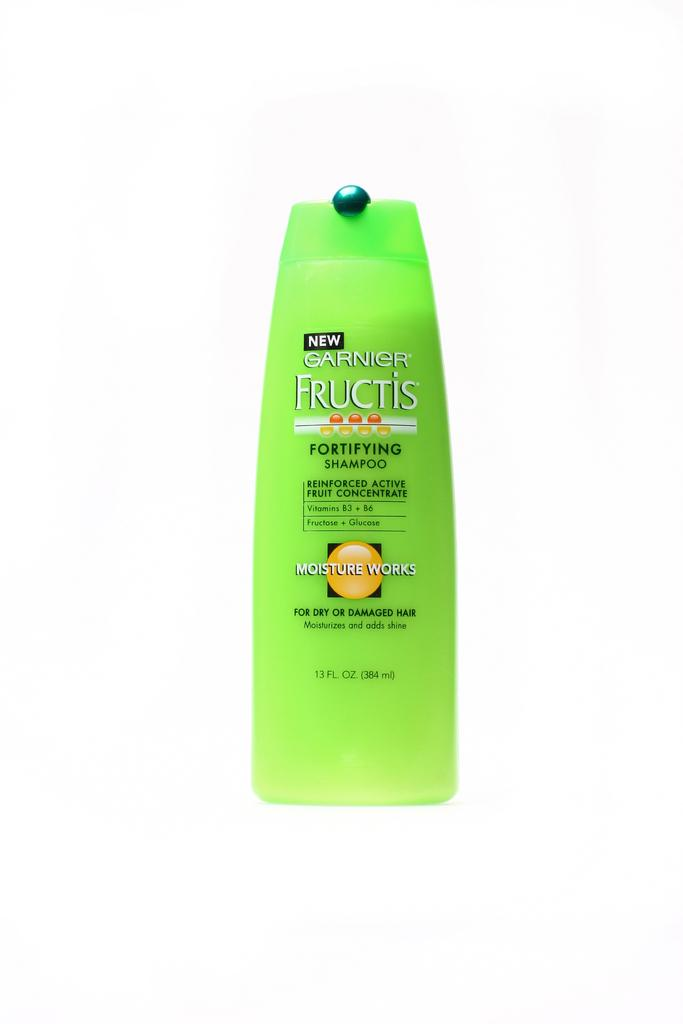<image>
Offer a succinct explanation of the picture presented. A green bottle of Fructis Fortifying Shampoo that says Moisture Works on it. 